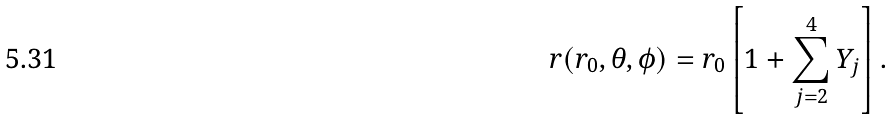Convert formula to latex. <formula><loc_0><loc_0><loc_500><loc_500>r ( r _ { 0 } , \theta , \phi ) = r _ { 0 } \left [ 1 + \sum ^ { 4 } _ { j = 2 } Y _ { j } \right ] .</formula> 